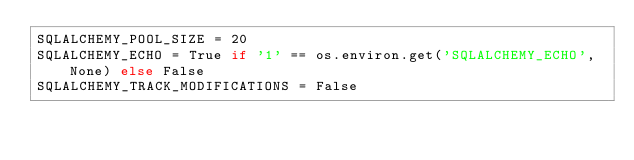Convert code to text. <code><loc_0><loc_0><loc_500><loc_500><_Python_>SQLALCHEMY_POOL_SIZE = 20
SQLALCHEMY_ECHO = True if '1' == os.environ.get('SQLALCHEMY_ECHO', None) else False
SQLALCHEMY_TRACK_MODIFICATIONS = False
</code> 